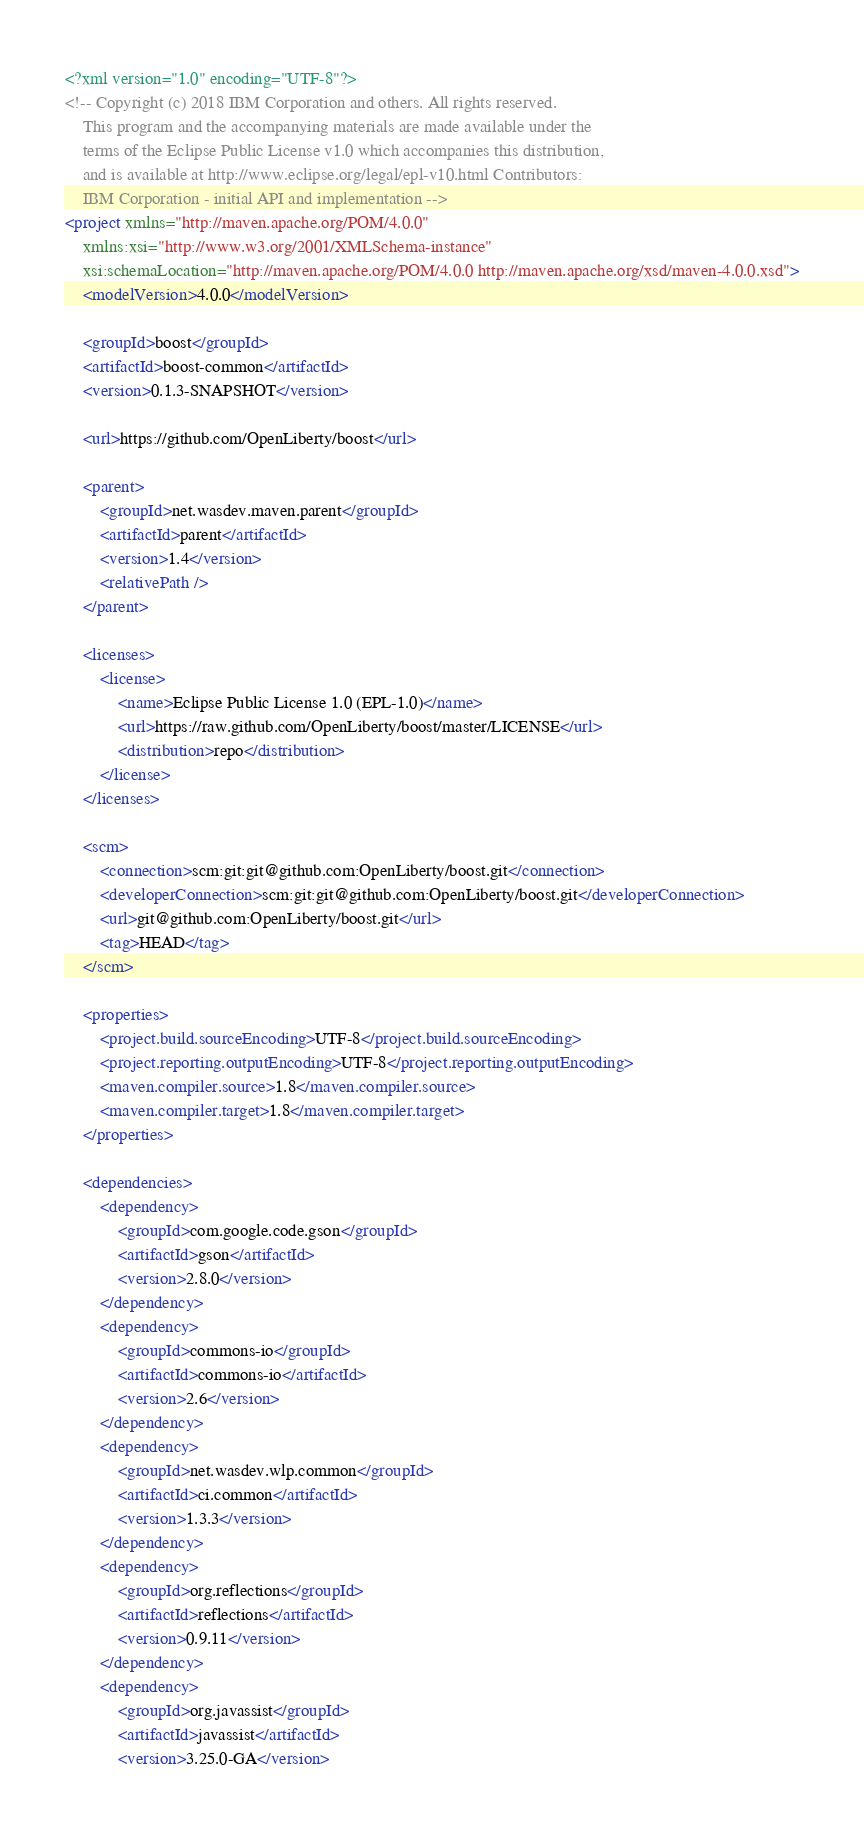<code> <loc_0><loc_0><loc_500><loc_500><_XML_><?xml version="1.0" encoding="UTF-8"?>
<!-- Copyright (c) 2018 IBM Corporation and others. All rights reserved. 
	This program and the accompanying materials are made available under the 
	terms of the Eclipse Public License v1.0 which accompanies this distribution, 
	and is available at http://www.eclipse.org/legal/epl-v10.html Contributors: 
	IBM Corporation - initial API and implementation -->
<project xmlns="http://maven.apache.org/POM/4.0.0"
	xmlns:xsi="http://www.w3.org/2001/XMLSchema-instance"
	xsi:schemaLocation="http://maven.apache.org/POM/4.0.0 http://maven.apache.org/xsd/maven-4.0.0.xsd">
	<modelVersion>4.0.0</modelVersion>

	<groupId>boost</groupId>
	<artifactId>boost-common</artifactId>
	<version>0.1.3-SNAPSHOT</version>

	<url>https://github.com/OpenLiberty/boost</url>

	<parent>
		<groupId>net.wasdev.maven.parent</groupId>
		<artifactId>parent</artifactId>
		<version>1.4</version>
		<relativePath />
	</parent>

	<licenses>
		<license>
			<name>Eclipse Public License 1.0 (EPL-1.0)</name>
			<url>https://raw.github.com/OpenLiberty/boost/master/LICENSE</url>
			<distribution>repo</distribution>
		</license>
	</licenses>

	<scm>
		<connection>scm:git:git@github.com:OpenLiberty/boost.git</connection>
		<developerConnection>scm:git:git@github.com:OpenLiberty/boost.git</developerConnection>
		<url>git@github.com:OpenLiberty/boost.git</url>
		<tag>HEAD</tag>
	</scm>

	<properties>
		<project.build.sourceEncoding>UTF-8</project.build.sourceEncoding>
		<project.reporting.outputEncoding>UTF-8</project.reporting.outputEncoding>
		<maven.compiler.source>1.8</maven.compiler.source>
		<maven.compiler.target>1.8</maven.compiler.target>
	</properties>

	<dependencies>
		<dependency>
			<groupId>com.google.code.gson</groupId>
			<artifactId>gson</artifactId>
			<version>2.8.0</version>
		</dependency>
		<dependency>
			<groupId>commons-io</groupId>
			<artifactId>commons-io</artifactId>
			<version>2.6</version>
		</dependency>
		<dependency>
			<groupId>net.wasdev.wlp.common</groupId>
			<artifactId>ci.common</artifactId>
			<version>1.3.3</version>
		</dependency>
		<dependency>
			<groupId>org.reflections</groupId>
			<artifactId>reflections</artifactId>
			<version>0.9.11</version>
		</dependency>
		<dependency>
			<groupId>org.javassist</groupId>
			<artifactId>javassist</artifactId>
			<version>3.25.0-GA</version></code> 